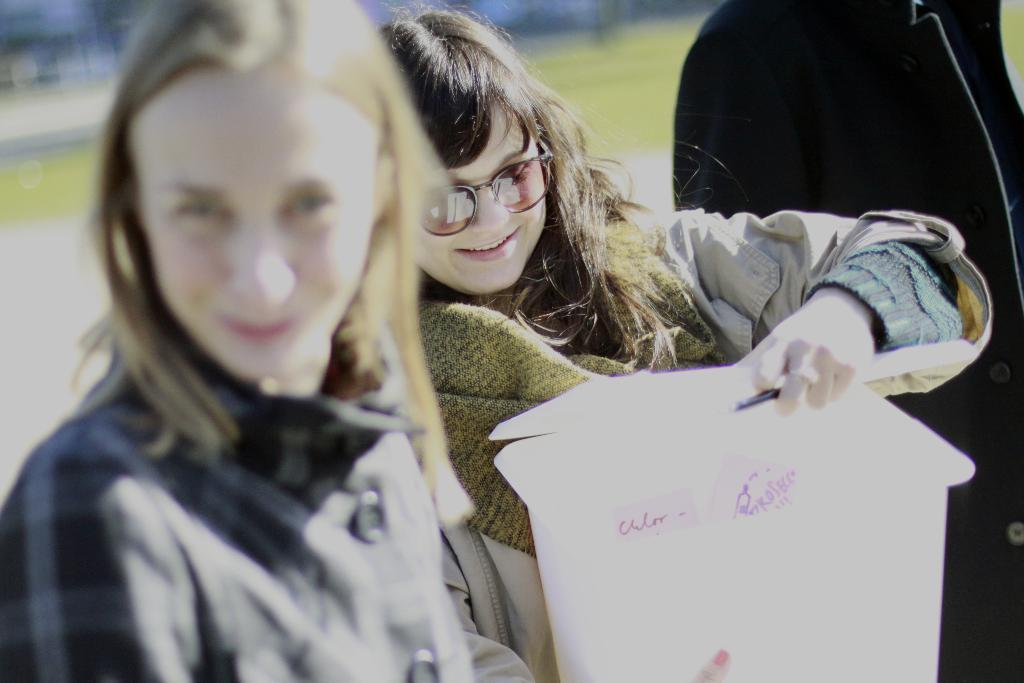How would you summarize this image in a sentence or two? this picture shows a woman wore sunglasses and she is holding a paper bag in her hand and we see a human standing and we see grass on the ground. 